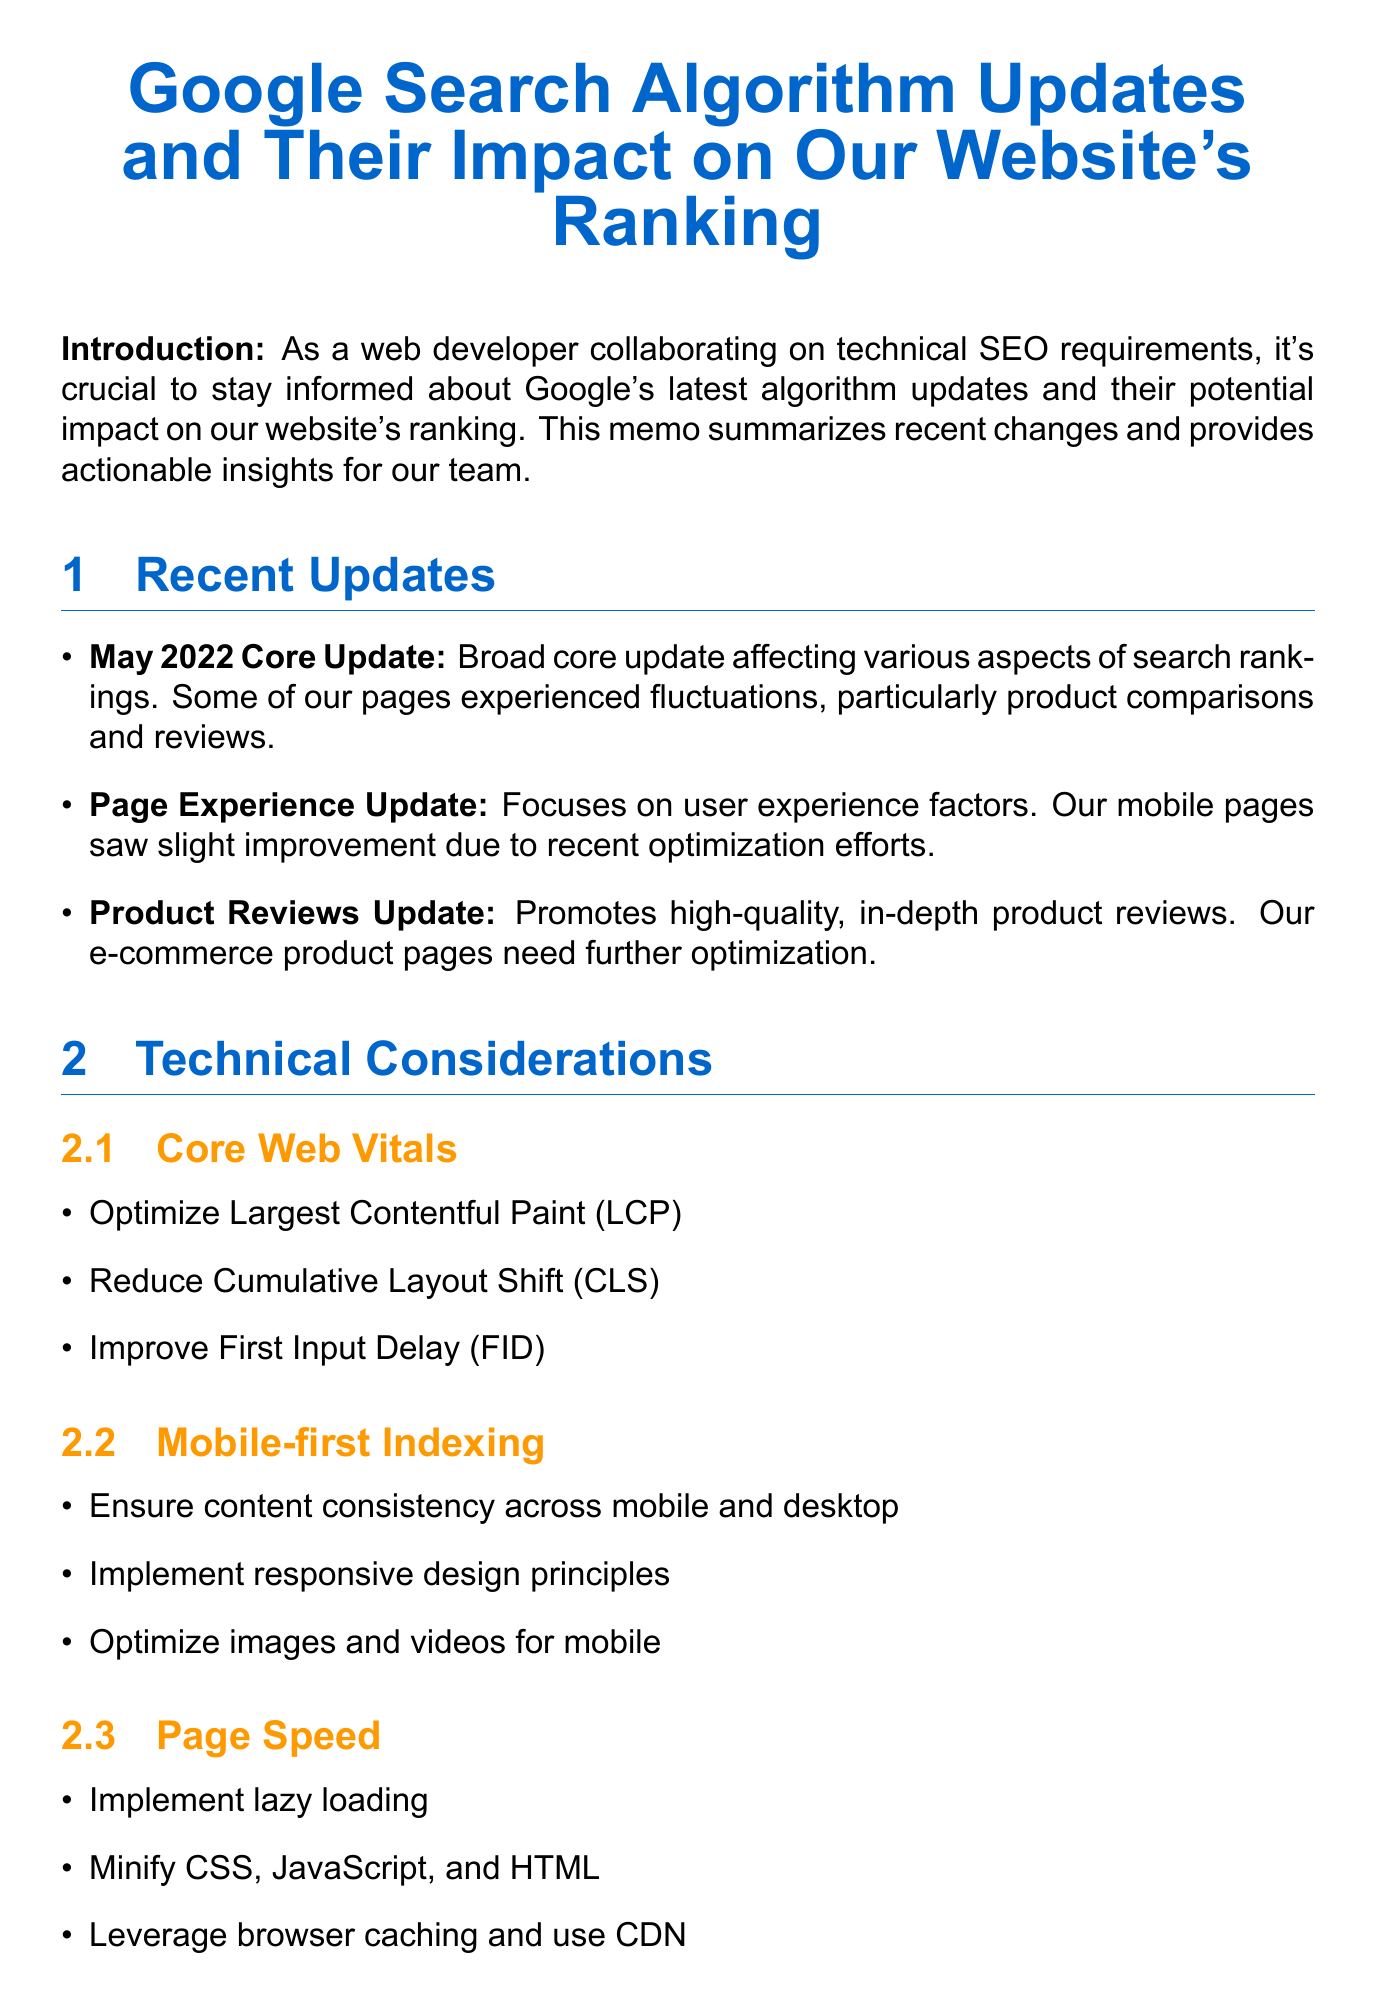what is the title of the memo? The title of the memo is stated at the beginning.
Answer: Google Search Algorithm Updates and Their Impact on Our Website's Ranking what was the impact of the May 2022 Core Update? The impact mentioned relates to certain pages experiencing fluctuations in rankings.
Answer: Fluctuations in rankings which aspect focuses on user experience factors? The aspect related to user experience is highlighted in the Technical Considerations section.
Answer: Page Experience Update what is one action item to optimize Largest Contentful Paint (LCP)? The document lists specific actions under Core Web Vitals.
Answer: Improving server response times what are the three action items under Page Speed? The action items listed are specific to optimizing page speed.
Answer: Lazy loading, minify CSS, leverage browser caching what does E-A-T stand for in the SEO implications? The document mentions E-A-T as a factor to enhance.
Answer: Expertise, Authoritativeness, Trustworthiness how many recent updates are listed in the memo? The number of updates can be calculated from the Recent Updates section.
Answer: Three which tool is used to monitor search performance? The tool used for monitoring is specified in the Tools and Resources section.
Answer: Google Search Console what is the first next step mentioned in the conclusion? The next steps are clearly outlined at the end of the memo.
Answer: Schedule a meeting with the SEO team 